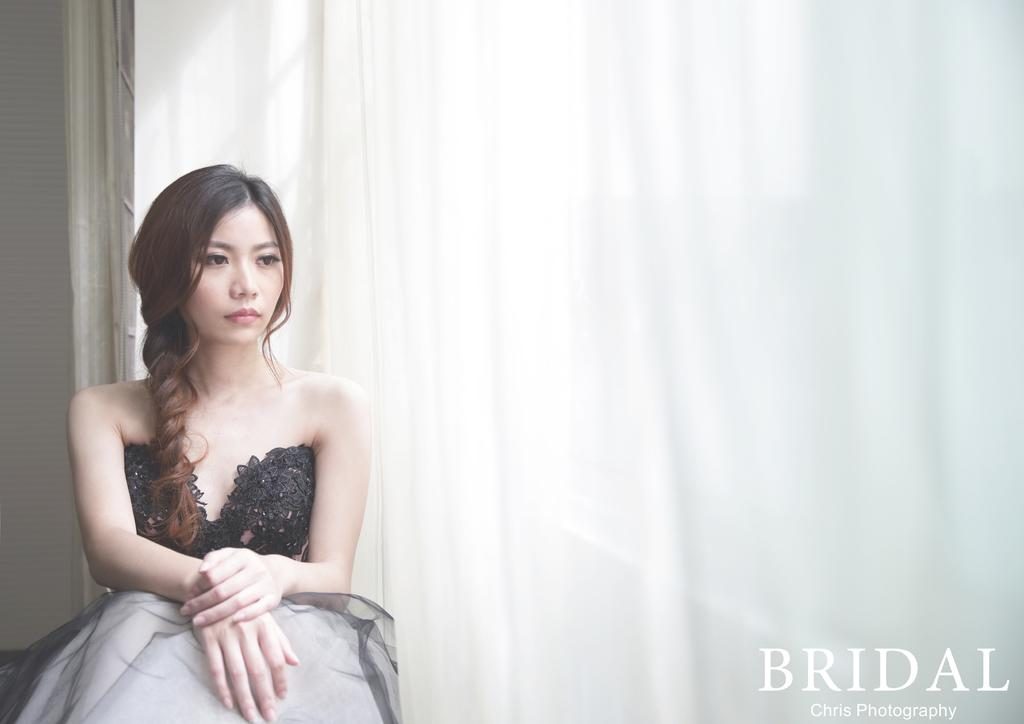What is the main subject of the image? There is a girl sitting in the image. What can be seen beside the girl? There is a curtain beside the girl. Where is the text located in the image? The text is at the bottom right side of the image. What type of thing is the girl walking on in the image? There is no indication in the image that the girl is walking, and no sidewalk or similar surface is visible. 